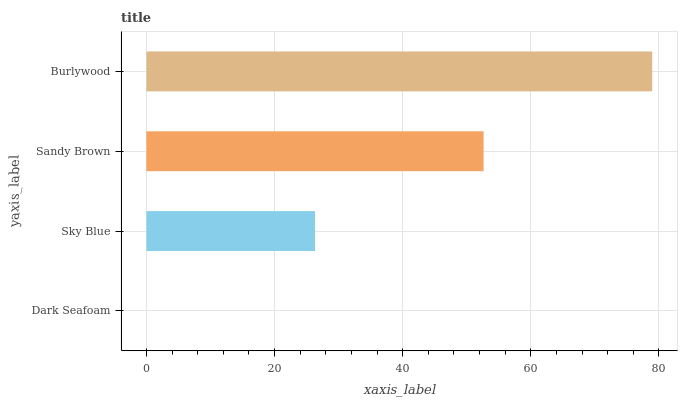Is Dark Seafoam the minimum?
Answer yes or no. Yes. Is Burlywood the maximum?
Answer yes or no. Yes. Is Sky Blue the minimum?
Answer yes or no. No. Is Sky Blue the maximum?
Answer yes or no. No. Is Sky Blue greater than Dark Seafoam?
Answer yes or no. Yes. Is Dark Seafoam less than Sky Blue?
Answer yes or no. Yes. Is Dark Seafoam greater than Sky Blue?
Answer yes or no. No. Is Sky Blue less than Dark Seafoam?
Answer yes or no. No. Is Sandy Brown the high median?
Answer yes or no. Yes. Is Sky Blue the low median?
Answer yes or no. Yes. Is Sky Blue the high median?
Answer yes or no. No. Is Sandy Brown the low median?
Answer yes or no. No. 